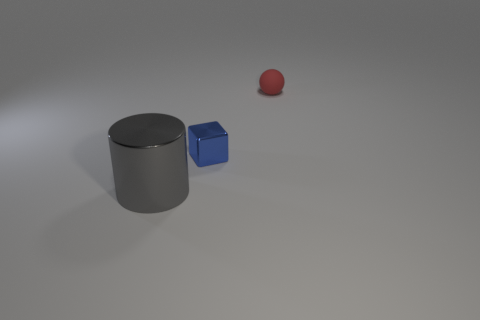Is there any other thing that is the same size as the gray metallic object?
Keep it short and to the point. No. Is there another small thing that has the same material as the gray object?
Provide a succinct answer. Yes. Does the cylinder have the same material as the tiny thing that is in front of the red rubber sphere?
Your response must be concise. Yes. What shape is the shiny object that is in front of the shiny thing behind the metal cylinder?
Provide a succinct answer. Cylinder. There is a metal thing behind the cylinder; is its size the same as the small red matte thing?
Provide a short and direct response. Yes. How many other objects are the same shape as the tiny blue metal thing?
Offer a very short reply. 0. There is a red rubber thing; how many gray cylinders are in front of it?
Keep it short and to the point. 1. What number of other things are there of the same size as the blue shiny cube?
Provide a succinct answer. 1. Does the tiny thing that is left of the ball have the same material as the red object behind the small blue object?
Keep it short and to the point. No. What color is the metallic thing that is the same size as the red sphere?
Your response must be concise. Blue. 